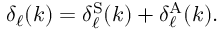<formula> <loc_0><loc_0><loc_500><loc_500>\delta _ { \ell } ( k ) = \delta _ { \ell } ^ { S } ( k ) + \delta _ { \ell } ^ { A } ( k ) .</formula> 